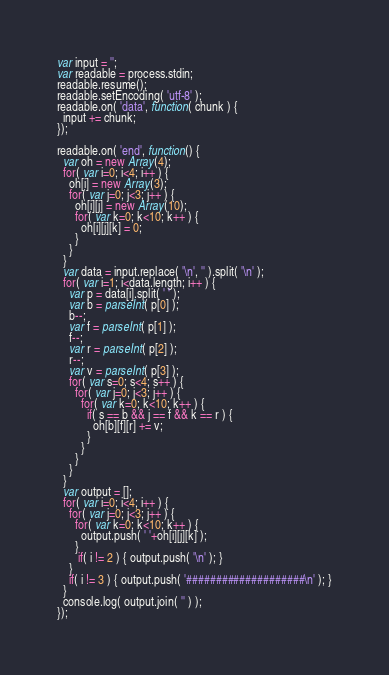<code> <loc_0><loc_0><loc_500><loc_500><_JavaScript_>var input = '';
var readable = process.stdin;
readable.resume();
readable.setEncoding( 'utf-8' );
readable.on( 'data', function( chunk ) {
  input += chunk;
});

readable.on( 'end', function() {
  var oh = new Array(4);
  for( var i=0; i<4; i++ ) {
    oh[i] = new Array(3);
    for( var j=0; j<3; j++ ) {
      oh[i][j] = new Array(10);
      for( var k=0; k<10; k++ ) {
        oh[i][j][k] = 0;
      }
    }
  }
  var data = input.replace( '\n', '' ).split( '\n' );
  for( var i=1; i<data.length; i++ ) {
    var p = data[i].split( ' ' );
    var b = parseInt( p[0] );
    b--;
    var f = parseInt( p[1] );
    f--;
    var r = parseInt( p[2] );
    r--;
    var v = parseInt( p[3] );
    for( var s=0; s<4; s++ ) {
      for( var j=0; j<3; j++ ) {
        for( var k=0; k<10; k++ ) {
          if( s == b && j == f && k == r ) {
            oh[b][f][r] += v;
          }
        }
      }
    }  
  }
  var output = [];
  for( var i=0; i<4; i++ ) {
    for( var j=0; j<3; j++ ) {
      for( var k=0; k<10; k++ ) {
        output.push( ' '+oh[i][j][k] );
      }
       if( i != 2 ) { output.push( '\n' ); }
    }
    if( i != 3 ) { output.push( '####################\n' ); }
  }
  console.log( output.join( '' ) );
});</code> 